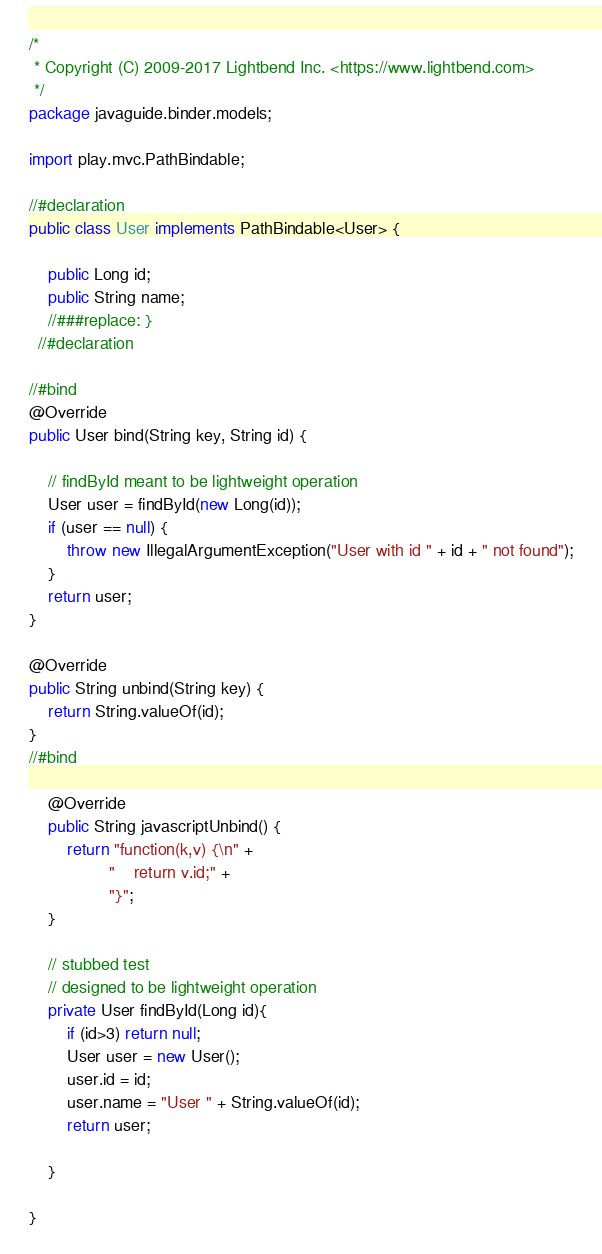<code> <loc_0><loc_0><loc_500><loc_500><_Java_>/*
 * Copyright (C) 2009-2017 Lightbend Inc. <https://www.lightbend.com>
 */
package javaguide.binder.models;

import play.mvc.PathBindable;

//#declaration
public class User implements PathBindable<User> {
	
    public Long id;
    public String name;
	//###replace: }
  //#declaration

//#bind
@Override
public User bind(String key, String id) {

	// findById meant to be lightweight operation
	User user = findById(new Long(id));
	if (user == null) {
		throw new IllegalArgumentException("User with id " + id + " not found");
	}
	return user;
}

@Override
public String unbind(String key) {
	return String.valueOf(id);
}
//#bind
	
	@Override
	public String javascriptUnbind() {
		return "function(k,v) {\n" +
	             "    return v.id;" +
	             "}";
	}
	
	// stubbed test 
	// designed to be lightweight operation
	private User findById(Long id){
		if (id>3) return null;
		User user = new User();
		user.id = id;
		user.name = "User " + String.valueOf(id);
		return user;
    	
	}

}
</code> 